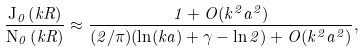Convert formula to latex. <formula><loc_0><loc_0><loc_500><loc_500>\frac { { \mathrm J } _ { 0 } \left ( k R \right ) } { { \mathrm N } _ { 0 } \left ( k R \right ) } \approx \frac { 1 + O ( k ^ { 2 } a ^ { 2 } ) } { ( 2 / \pi ) ( \ln ( k a ) + \gamma - \ln 2 ) + O ( k ^ { 2 } a ^ { 2 } ) } ,</formula> 